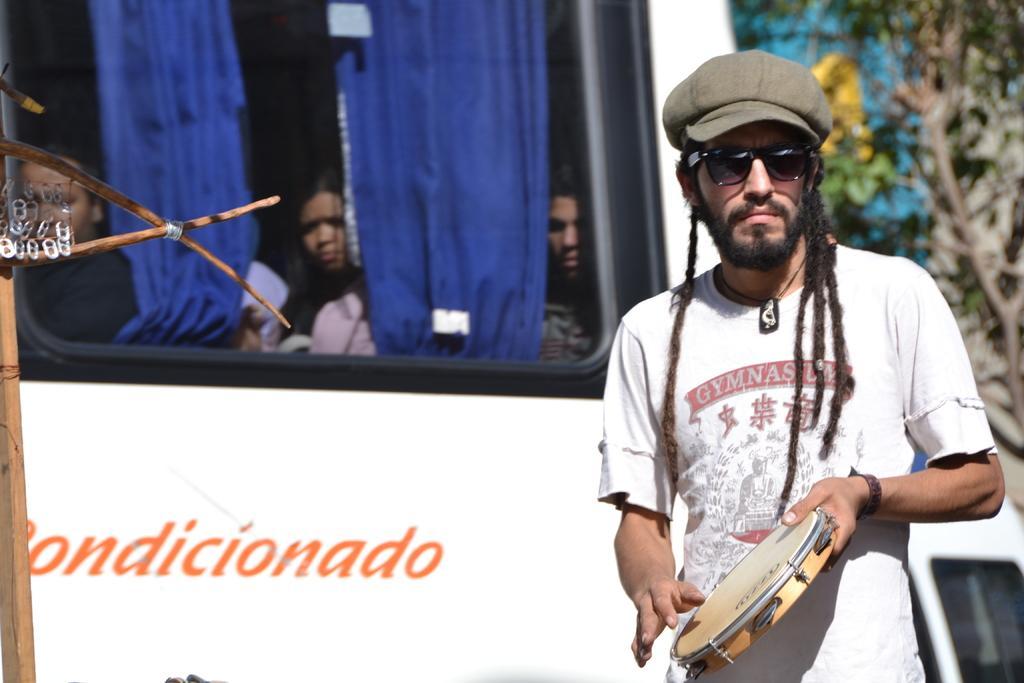How would you summarize this image in a sentence or two? In this picture I can see a person holding the musical instrument on the right side. I can see a few people in the bus. I can see the blue color curtains. 